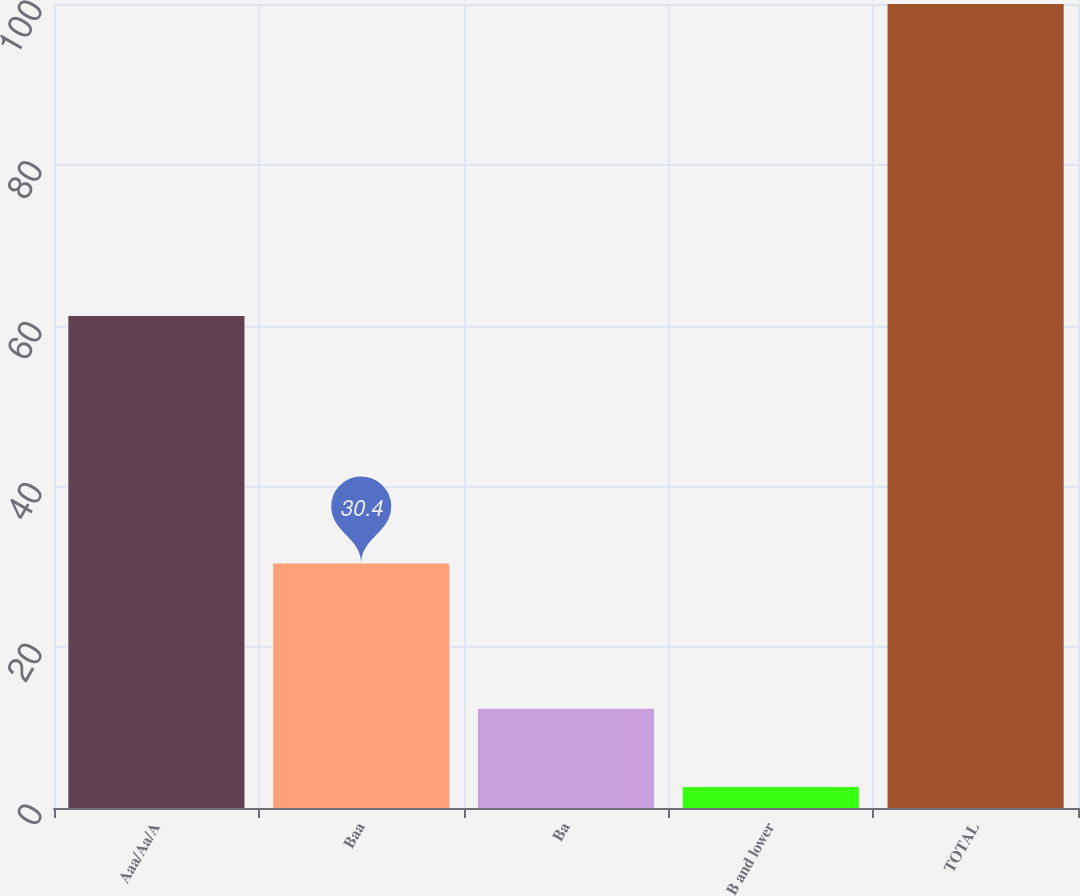<chart> <loc_0><loc_0><loc_500><loc_500><bar_chart><fcel>Aaa/Aa/A<fcel>Baa<fcel>Ba<fcel>B and lower<fcel>TOTAL<nl><fcel>61.2<fcel>30.4<fcel>12.34<fcel>2.6<fcel>100<nl></chart> 